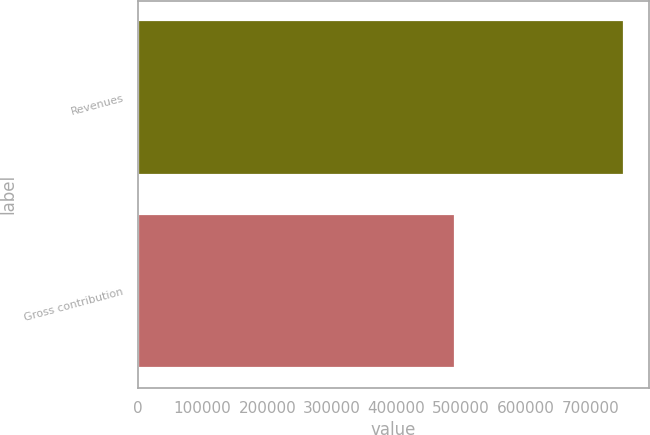<chart> <loc_0><loc_0><loc_500><loc_500><bar_chart><fcel>Revenues<fcel>Gross contribution<nl><fcel>752505<fcel>489862<nl></chart> 